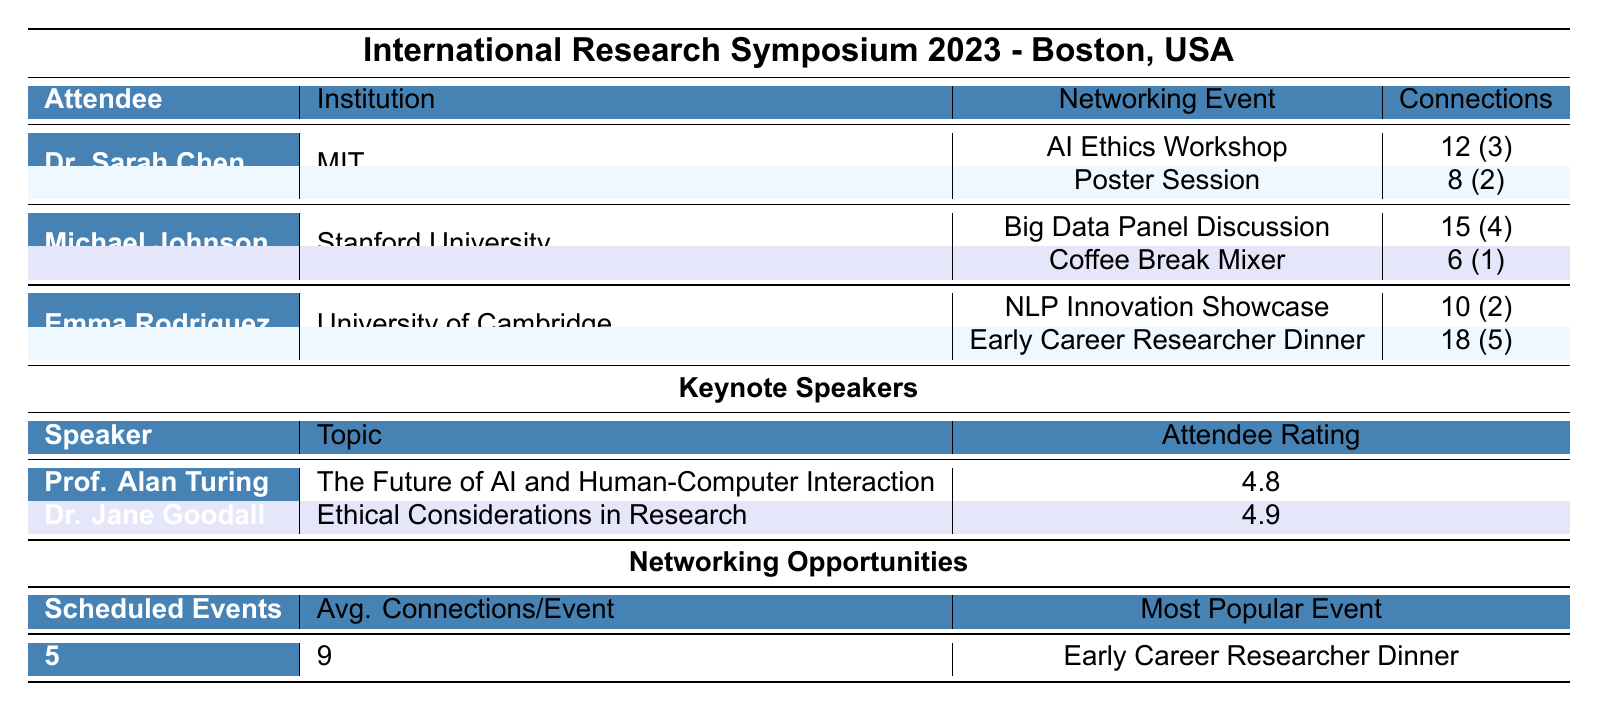What is the total number of connections Dr. Sarah Chen made at the conference? Dr. Sarah Chen made 12 connections at the AI Ethics Workshop and 8 connections at the Poster Session. To find the total, we sum these numbers: 12 + 8 = 20.
Answer: 20 Which keynote speaker had the highest attendee rating? The table shows that Dr. Jane Goodall has an attendee rating of 4.9, which is higher than Prof. Alan Turing's rating of 4.8. Thus, Dr. Jane Goodall had the highest rating.
Answer: Dr. Jane Goodall How many connections did Emma Rodriguez make in total? Emma Rodriguez made 10 connections at the NLP Innovation Showcase and 18 connections at the Early Career Researcher Dinner. Adding these gives us 10 + 18 = 28 connections.
Answer: 28 Is the "Early Career Researcher Dinner" considered the most popular event based on average connections? The table states that the Early Career Researcher Dinner is labeled as the most popular event. Therefore, it confirms that it is indeed the most popular event based on connections made.
Answer: Yes What is the average number of connections made per scheduled event at the networking opportunities? There are 5 scheduled events, and the total average connections per event listed is 9. This value is already provided in the table, so no additional calculations are needed.
Answer: 9 How many potential collaborations were noted by Michael Johnson during his networking events? Michael Johnson had 4 potential collaborations from the Big Data Panel Discussion and 1 from the Coffee Break Mixer. Adding these gives us 4 + 1 = 5 potential collaborations.
Answer: 5 Which institution had an attendee with the most connections? Emma Rodriguez from the University of Cambridge made 28 connections total (10 + 18), which is more than any connections made by other attendees. Therefore, her institution ranks first in connections.
Answer: University of Cambridge What are the topics covered in the workshops? The table lists three workshop topics: "Grant Writing for Early Career Researchers," "Publishing in High-Impact Journals," and "Building International Research Networks." This directly provides the topics covered.
Answer: Grant Writing for Early Career Researchers, Publishing in High-Impact Journals, Building International Research Networks How many attendees are listed in the table, and what is their average number of potential collaborations? There are three attendees listed. The potential collaborations from Dr. Sarah Chen (2), Michael Johnson (5), and Emma Rodriguez (5) add up to 12. The average is calculated as 12/3 = 4.
Answer: 4 Was there a networking event that Dr. Sarah Chen attended where she made more connections than at the Poster Session? Yes, Dr. Sarah Chen made 12 connections at the AI Ethics Workshop, which is more than the 8 connections she made at the Poster Session.
Answer: Yes 